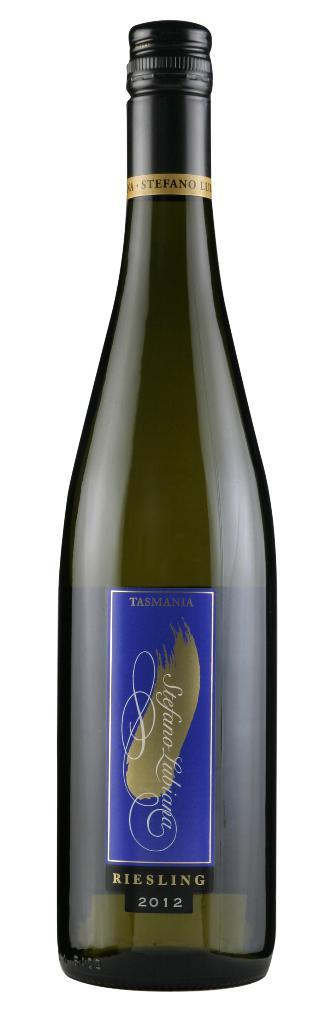<image>
Describe the image concisely. There's nothing like an unopened bottle of Riesling 2012. 